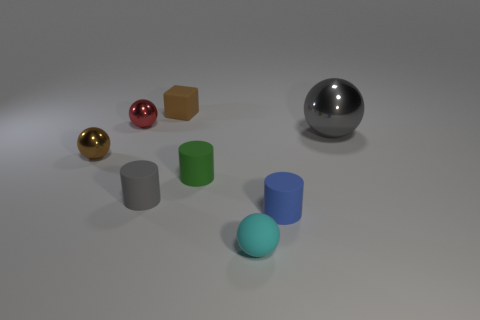Is there any other thing that is the same size as the gray sphere?
Ensure brevity in your answer.  No. What number of matte things are either things or gray things?
Offer a terse response. 5. Do the gray cylinder and the cube have the same material?
Offer a very short reply. Yes. There is a tiny metal object behind the large gray thing; what shape is it?
Offer a very short reply. Sphere. Is there a large shiny sphere to the right of the small metal sphere on the left side of the red metallic sphere?
Give a very brief answer. Yes. Is there a brown sphere of the same size as the brown block?
Provide a short and direct response. Yes. Does the tiny shiny ball in front of the gray ball have the same color as the tiny rubber cube?
Your answer should be compact. Yes. The rubber cube is what size?
Give a very brief answer. Small. There is a metal thing that is to the right of the small rubber cylinder that is in front of the gray cylinder; what is its size?
Ensure brevity in your answer.  Large. What number of other matte balls have the same color as the big sphere?
Give a very brief answer. 0. 